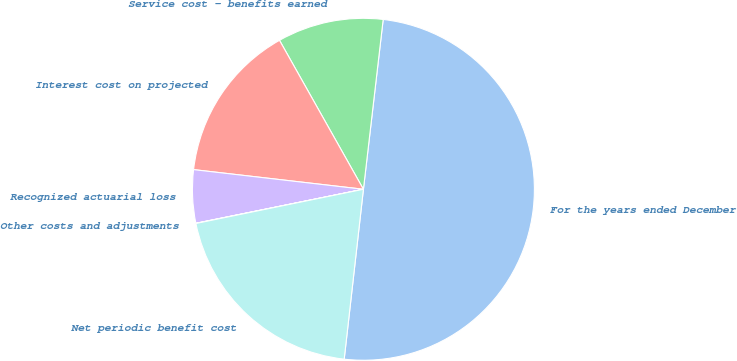Convert chart. <chart><loc_0><loc_0><loc_500><loc_500><pie_chart><fcel>For the years ended December<fcel>Service cost - benefits earned<fcel>Interest cost on projected<fcel>Recognized actuarial loss<fcel>Other costs and adjustments<fcel>Net periodic benefit cost<nl><fcel>49.95%<fcel>10.01%<fcel>15.0%<fcel>5.02%<fcel>0.02%<fcel>20.0%<nl></chart> 